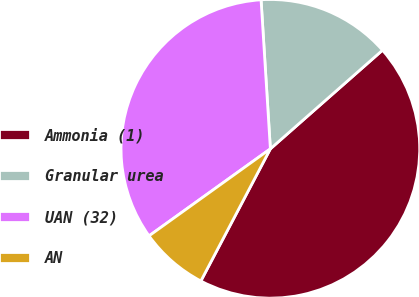<chart> <loc_0><loc_0><loc_500><loc_500><pie_chart><fcel>Ammonia (1)<fcel>Granular urea<fcel>UAN (32)<fcel>AN<nl><fcel>44.19%<fcel>14.51%<fcel>33.91%<fcel>7.39%<nl></chart> 